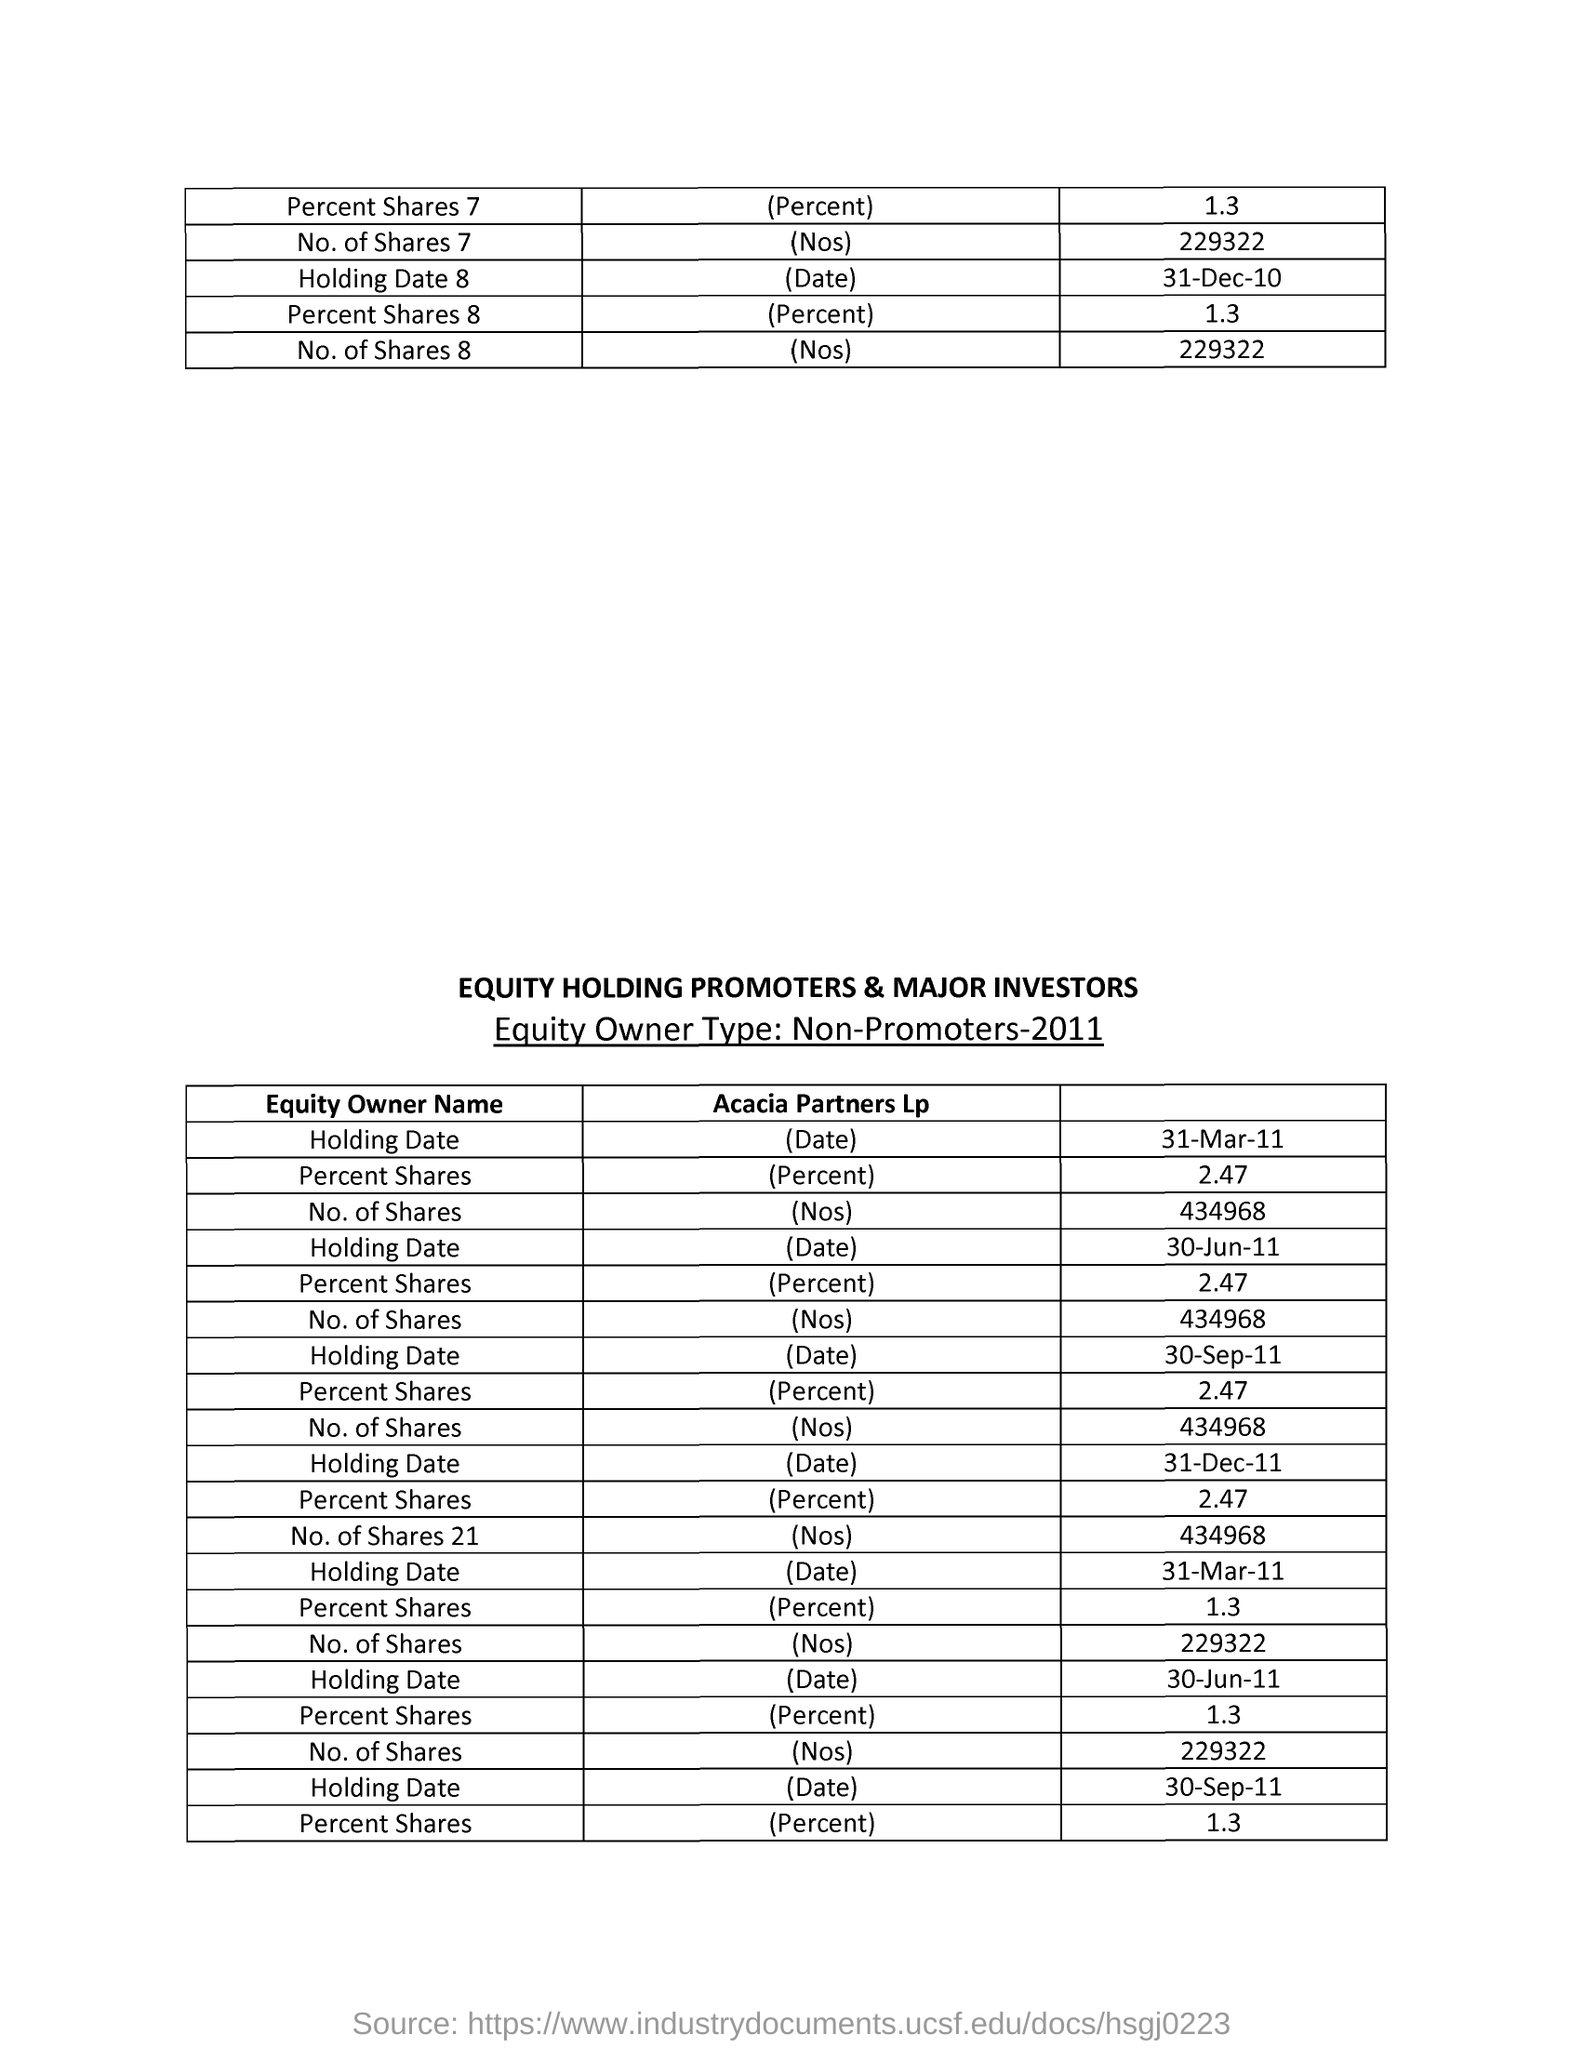What is the year in which equity owner type:non promoters?
Offer a very short reply. 2011. What is the total number of shares 21 in acacia partners lp?
Provide a short and direct response. 434968. 